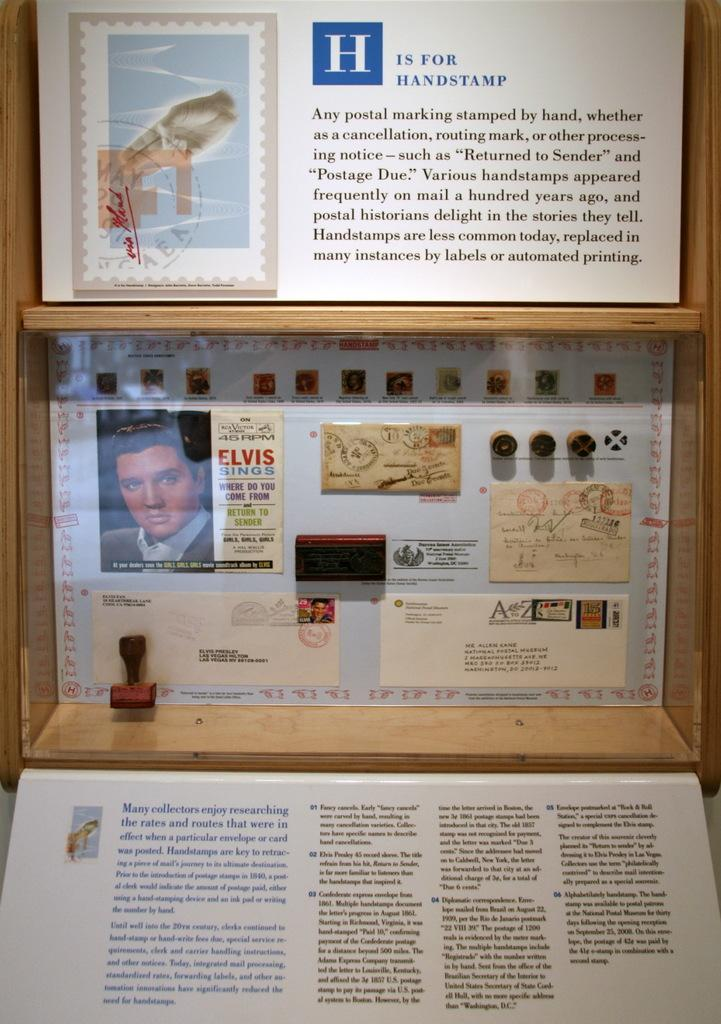Provide a one-sentence caption for the provided image. A display about postage with a picture of Elvis that says Elvis sings and under it has a list of his songs. 